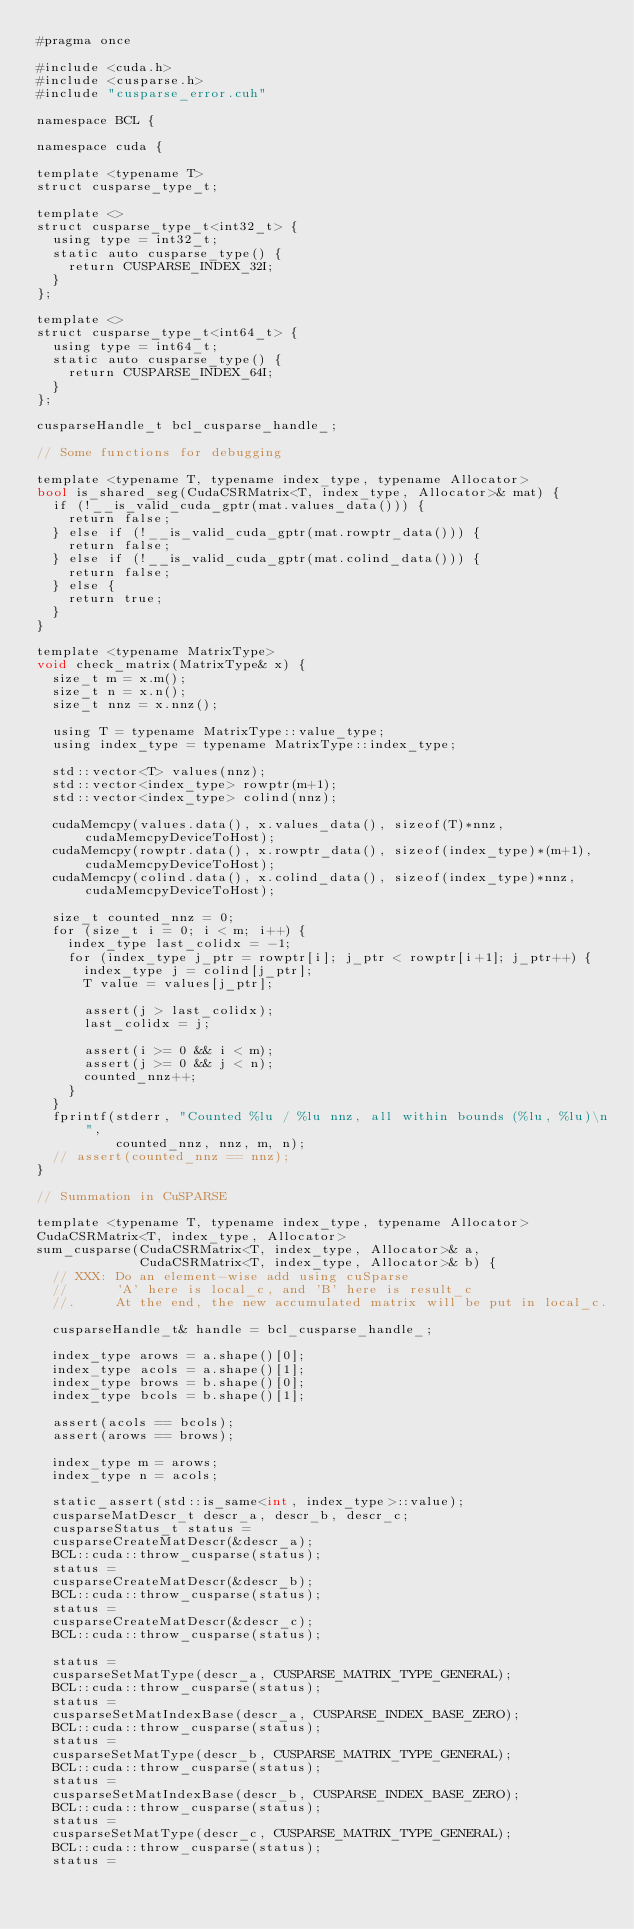<code> <loc_0><loc_0><loc_500><loc_500><_Cuda_>#pragma once

#include <cuda.h>
#include <cusparse.h>
#include "cusparse_error.cuh"

namespace BCL {

namespace cuda {

template <typename T>
struct cusparse_type_t;

template <>
struct cusparse_type_t<int32_t> {
  using type = int32_t;
  static auto cusparse_type() {
    return CUSPARSE_INDEX_32I;
  }
};

template <>
struct cusparse_type_t<int64_t> {
  using type = int64_t;
  static auto cusparse_type() {
    return CUSPARSE_INDEX_64I;
  }
};

cusparseHandle_t bcl_cusparse_handle_;

// Some functions for debugging

template <typename T, typename index_type, typename Allocator>
bool is_shared_seg(CudaCSRMatrix<T, index_type, Allocator>& mat) {
  if (!__is_valid_cuda_gptr(mat.values_data())) {
    return false;
  } else if (!__is_valid_cuda_gptr(mat.rowptr_data())) {
    return false;
  } else if (!__is_valid_cuda_gptr(mat.colind_data())) {
    return false;
  } else {
    return true;
  }
}

template <typename MatrixType>
void check_matrix(MatrixType& x) {
  size_t m = x.m();
  size_t n = x.n();
  size_t nnz = x.nnz();

  using T = typename MatrixType::value_type;
  using index_type = typename MatrixType::index_type;

  std::vector<T> values(nnz);
  std::vector<index_type> rowptr(m+1);
  std::vector<index_type> colind(nnz);

  cudaMemcpy(values.data(), x.values_data(), sizeof(T)*nnz, cudaMemcpyDeviceToHost);
  cudaMemcpy(rowptr.data(), x.rowptr_data(), sizeof(index_type)*(m+1), cudaMemcpyDeviceToHost);
  cudaMemcpy(colind.data(), x.colind_data(), sizeof(index_type)*nnz, cudaMemcpyDeviceToHost);

  size_t counted_nnz = 0;
  for (size_t i = 0; i < m; i++) {
    index_type last_colidx = -1;
    for (index_type j_ptr = rowptr[i]; j_ptr < rowptr[i+1]; j_ptr++) {
      index_type j = colind[j_ptr];
      T value = values[j_ptr];

      assert(j > last_colidx);
      last_colidx = j;

      assert(i >= 0 && i < m);
      assert(j >= 0 && j < n);
      counted_nnz++;
    }
  }
  fprintf(stderr, "Counted %lu / %lu nnz, all within bounds (%lu, %lu)\n",
          counted_nnz, nnz, m, n);
  // assert(counted_nnz == nnz);
}

// Summation in CuSPARSE

template <typename T, typename index_type, typename Allocator>
CudaCSRMatrix<T, index_type, Allocator>
sum_cusparse(CudaCSRMatrix<T, index_type, Allocator>& a,
             CudaCSRMatrix<T, index_type, Allocator>& b) {
  // XXX: Do an element-wise add using cuSparse
  //      'A' here is local_c, and 'B' here is result_c
  //.     At the end, the new accumulated matrix will be put in local_c.

  cusparseHandle_t& handle = bcl_cusparse_handle_;

  index_type arows = a.shape()[0];
  index_type acols = a.shape()[1];
  index_type brows = b.shape()[0];
  index_type bcols = b.shape()[1];

  assert(acols == bcols);
  assert(arows == brows);

  index_type m = arows;
  index_type n = acols;

  static_assert(std::is_same<int, index_type>::value);
  cusparseMatDescr_t descr_a, descr_b, descr_c;
  cusparseStatus_t status = 
  cusparseCreateMatDescr(&descr_a);
  BCL::cuda::throw_cusparse(status);
  status =
  cusparseCreateMatDescr(&descr_b);
  BCL::cuda::throw_cusparse(status);
  status =
  cusparseCreateMatDescr(&descr_c);
  BCL::cuda::throw_cusparse(status);

  status =
  cusparseSetMatType(descr_a, CUSPARSE_MATRIX_TYPE_GENERAL);
  BCL::cuda::throw_cusparse(status);
  status =
  cusparseSetMatIndexBase(descr_a, CUSPARSE_INDEX_BASE_ZERO);
  BCL::cuda::throw_cusparse(status);
  status =
  cusparseSetMatType(descr_b, CUSPARSE_MATRIX_TYPE_GENERAL);
  BCL::cuda::throw_cusparse(status);
  status =
  cusparseSetMatIndexBase(descr_b, CUSPARSE_INDEX_BASE_ZERO);
  BCL::cuda::throw_cusparse(status);
  status =
  cusparseSetMatType(descr_c, CUSPARSE_MATRIX_TYPE_GENERAL);
  BCL::cuda::throw_cusparse(status);
  status =</code> 